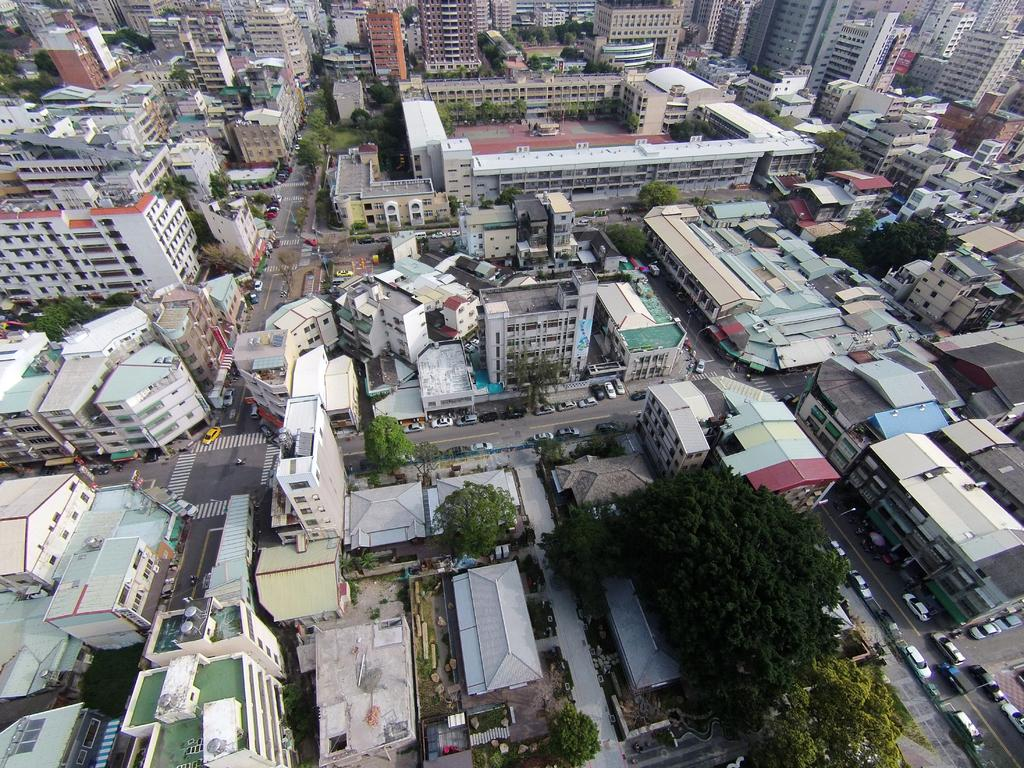What type of natural elements can be seen at the bottom of the image? There are trees at the bottom of the image. What type of man-made structures are present in the middle of the image? There are buildings in the middle of the image. What type of transportation is visible on the road in the image? There are vehicles on the road in the image. How many eyes can be seen on the trees in the image? Trees do not have eyes, so there are no eyes visible on the trees in the image. What type of ocean waves can be seen in the image? There are no ocean waves present in the image; it features trees, buildings, and vehicles. 